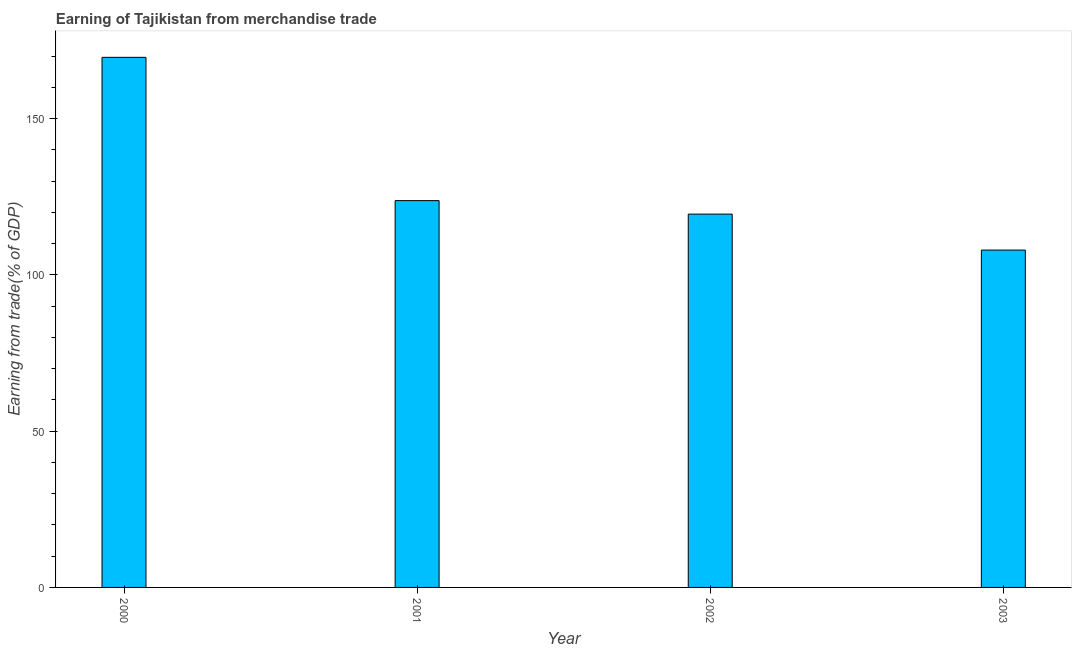Does the graph contain grids?
Your response must be concise. No. What is the title of the graph?
Your answer should be very brief. Earning of Tajikistan from merchandise trade. What is the label or title of the Y-axis?
Offer a terse response. Earning from trade(% of GDP). What is the earning from merchandise trade in 2000?
Ensure brevity in your answer.  169.66. Across all years, what is the maximum earning from merchandise trade?
Offer a terse response. 169.66. Across all years, what is the minimum earning from merchandise trade?
Make the answer very short. 107.97. In which year was the earning from merchandise trade maximum?
Keep it short and to the point. 2000. What is the sum of the earning from merchandise trade?
Offer a terse response. 520.91. What is the difference between the earning from merchandise trade in 2001 and 2002?
Make the answer very short. 4.32. What is the average earning from merchandise trade per year?
Your answer should be compact. 130.23. What is the median earning from merchandise trade?
Your answer should be compact. 121.64. What is the ratio of the earning from merchandise trade in 2001 to that in 2003?
Make the answer very short. 1.15. Is the earning from merchandise trade in 2002 less than that in 2003?
Give a very brief answer. No. Is the difference between the earning from merchandise trade in 2002 and 2003 greater than the difference between any two years?
Your response must be concise. No. What is the difference between the highest and the second highest earning from merchandise trade?
Ensure brevity in your answer.  45.86. What is the difference between the highest and the lowest earning from merchandise trade?
Provide a short and direct response. 61.69. How many bars are there?
Provide a succinct answer. 4. Are all the bars in the graph horizontal?
Your response must be concise. No. How many years are there in the graph?
Offer a terse response. 4. What is the Earning from trade(% of GDP) in 2000?
Your response must be concise. 169.66. What is the Earning from trade(% of GDP) of 2001?
Provide a short and direct response. 123.8. What is the Earning from trade(% of GDP) in 2002?
Offer a very short reply. 119.48. What is the Earning from trade(% of GDP) of 2003?
Provide a short and direct response. 107.97. What is the difference between the Earning from trade(% of GDP) in 2000 and 2001?
Ensure brevity in your answer.  45.86. What is the difference between the Earning from trade(% of GDP) in 2000 and 2002?
Your answer should be compact. 50.18. What is the difference between the Earning from trade(% of GDP) in 2000 and 2003?
Your answer should be compact. 61.69. What is the difference between the Earning from trade(% of GDP) in 2001 and 2002?
Your answer should be compact. 4.32. What is the difference between the Earning from trade(% of GDP) in 2001 and 2003?
Your answer should be very brief. 15.83. What is the difference between the Earning from trade(% of GDP) in 2002 and 2003?
Give a very brief answer. 11.51. What is the ratio of the Earning from trade(% of GDP) in 2000 to that in 2001?
Offer a very short reply. 1.37. What is the ratio of the Earning from trade(% of GDP) in 2000 to that in 2002?
Provide a short and direct response. 1.42. What is the ratio of the Earning from trade(% of GDP) in 2000 to that in 2003?
Offer a very short reply. 1.57. What is the ratio of the Earning from trade(% of GDP) in 2001 to that in 2002?
Your answer should be compact. 1.04. What is the ratio of the Earning from trade(% of GDP) in 2001 to that in 2003?
Give a very brief answer. 1.15. What is the ratio of the Earning from trade(% of GDP) in 2002 to that in 2003?
Offer a very short reply. 1.11. 